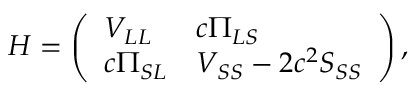<formula> <loc_0><loc_0><loc_500><loc_500>H = \left ( \begin{array} { l l } { V _ { L L } } & { c \Pi _ { L S } } \\ { c \Pi _ { S L } } & { V _ { S S } - 2 c ^ { 2 } S _ { S S } } \end{array} \right ) ,</formula> 